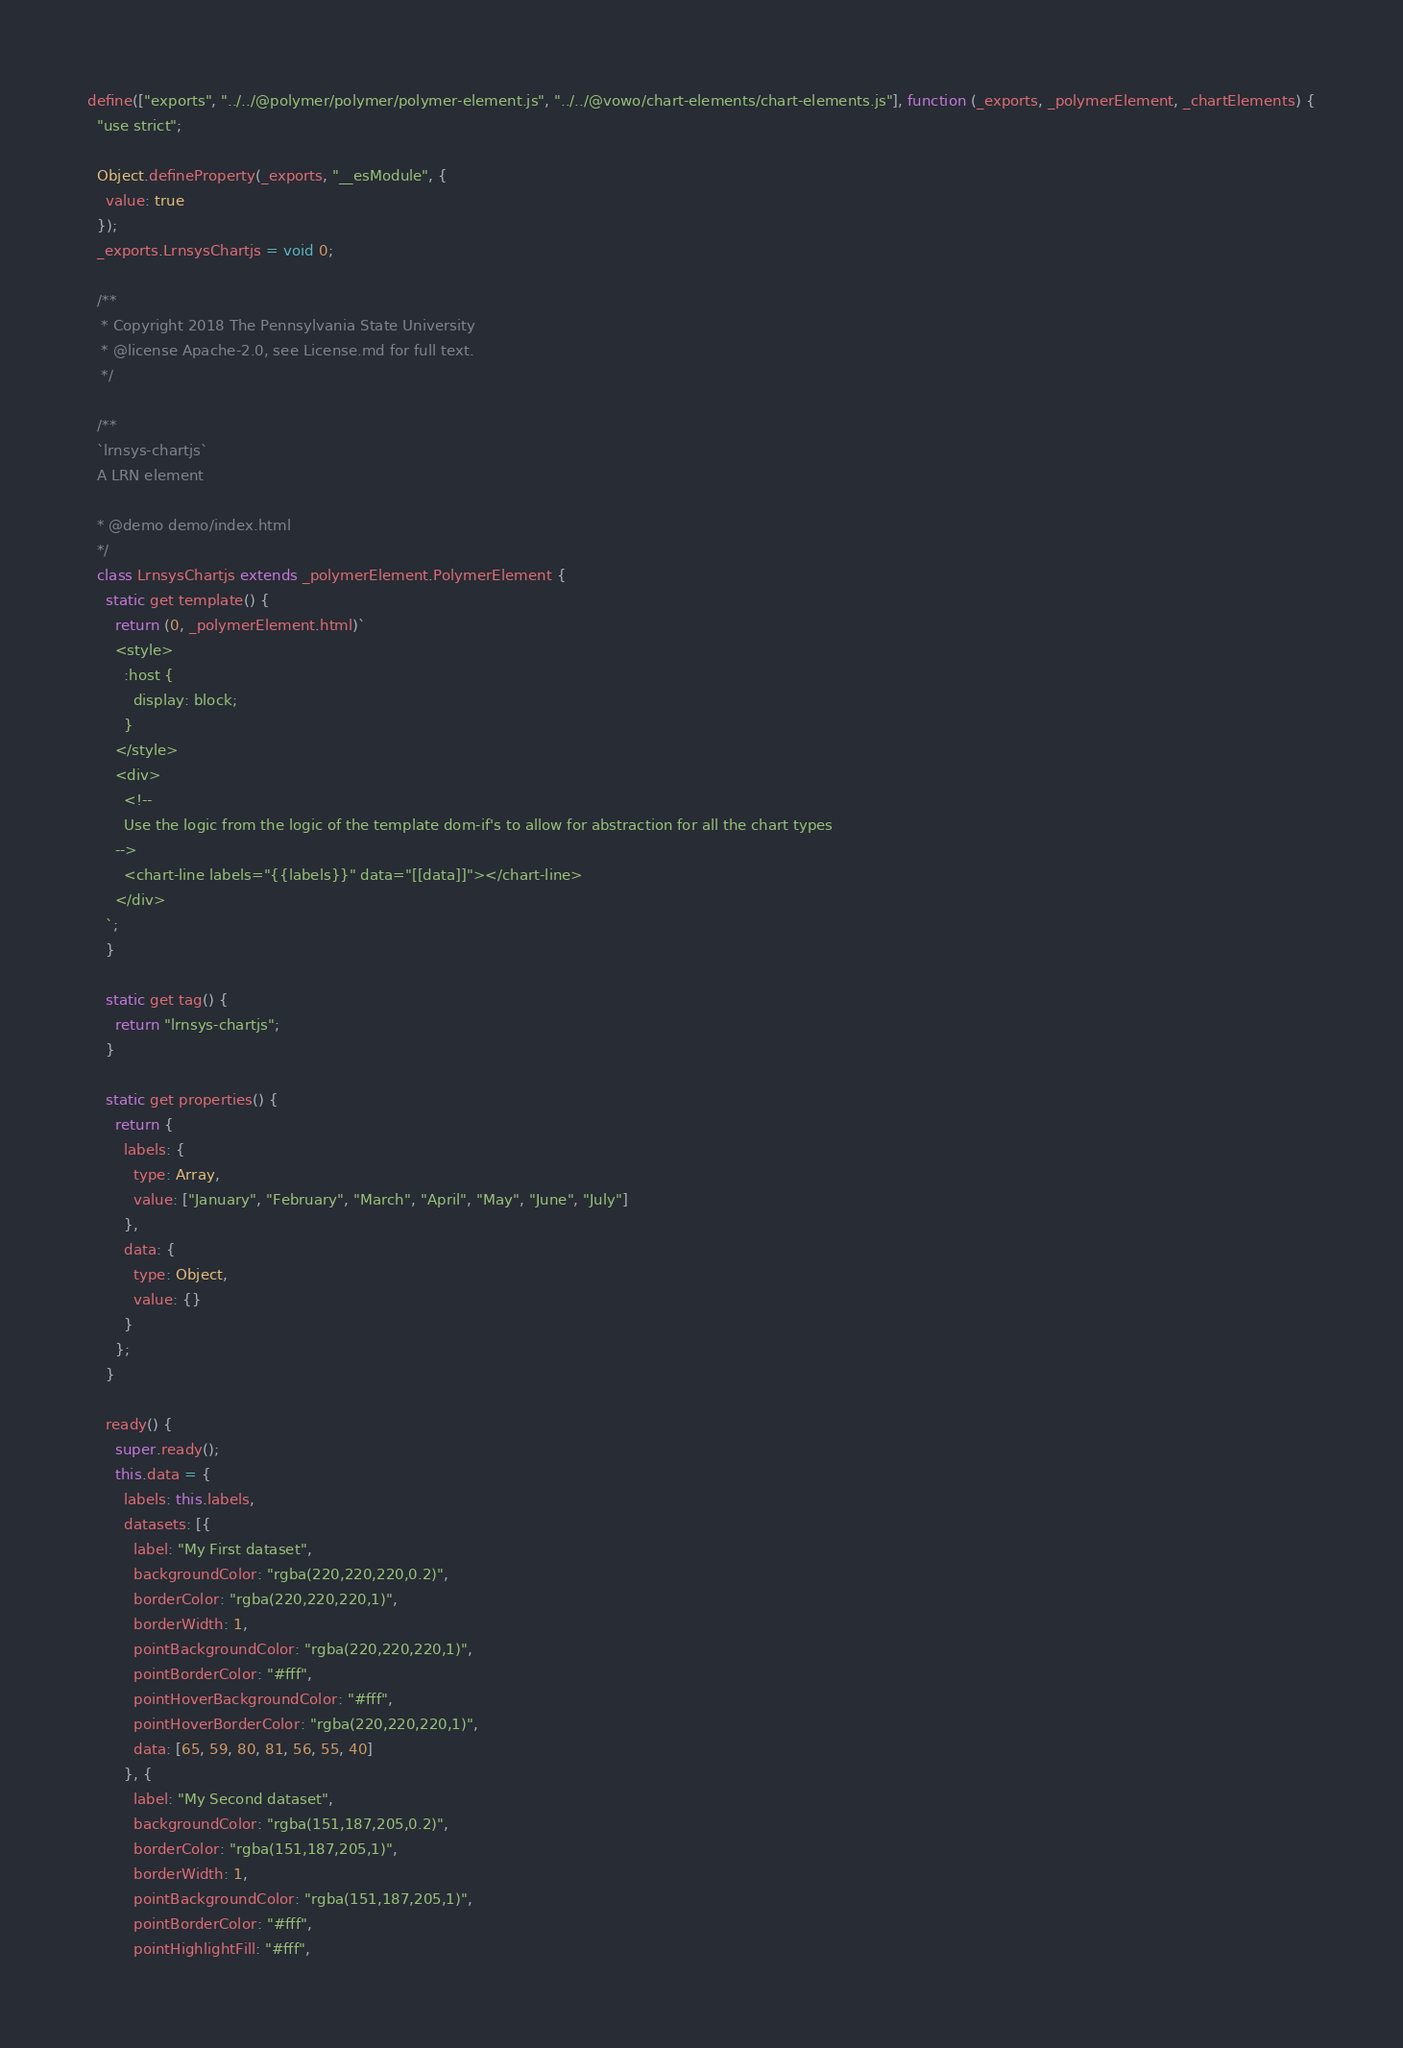<code> <loc_0><loc_0><loc_500><loc_500><_JavaScript_>define(["exports", "../../@polymer/polymer/polymer-element.js", "../../@vowo/chart-elements/chart-elements.js"], function (_exports, _polymerElement, _chartElements) {
  "use strict";

  Object.defineProperty(_exports, "__esModule", {
    value: true
  });
  _exports.LrnsysChartjs = void 0;

  /**
   * Copyright 2018 The Pennsylvania State University
   * @license Apache-2.0, see License.md for full text.
   */

  /**
  `lrnsys-chartjs`
  A LRN element
  
  * @demo demo/index.html
  */
  class LrnsysChartjs extends _polymerElement.PolymerElement {
    static get template() {
      return (0, _polymerElement.html)`
      <style>
        :host {
          display: block;
        }
      </style>
      <div>
        <!--
        Use the logic from the logic of the template dom-if's to allow for abstraction for all the chart types
      -->
        <chart-line labels="{{labels}}" data="[[data]]"></chart-line>
      </div>
    `;
    }

    static get tag() {
      return "lrnsys-chartjs";
    }

    static get properties() {
      return {
        labels: {
          type: Array,
          value: ["January", "February", "March", "April", "May", "June", "July"]
        },
        data: {
          type: Object,
          value: {}
        }
      };
    }

    ready() {
      super.ready();
      this.data = {
        labels: this.labels,
        datasets: [{
          label: "My First dataset",
          backgroundColor: "rgba(220,220,220,0.2)",
          borderColor: "rgba(220,220,220,1)",
          borderWidth: 1,
          pointBackgroundColor: "rgba(220,220,220,1)",
          pointBorderColor: "#fff",
          pointHoverBackgroundColor: "#fff",
          pointHoverBorderColor: "rgba(220,220,220,1)",
          data: [65, 59, 80, 81, 56, 55, 40]
        }, {
          label: "My Second dataset",
          backgroundColor: "rgba(151,187,205,0.2)",
          borderColor: "rgba(151,187,205,1)",
          borderWidth: 1,
          pointBackgroundColor: "rgba(151,187,205,1)",
          pointBorderColor: "#fff",
          pointHighlightFill: "#fff",</code> 